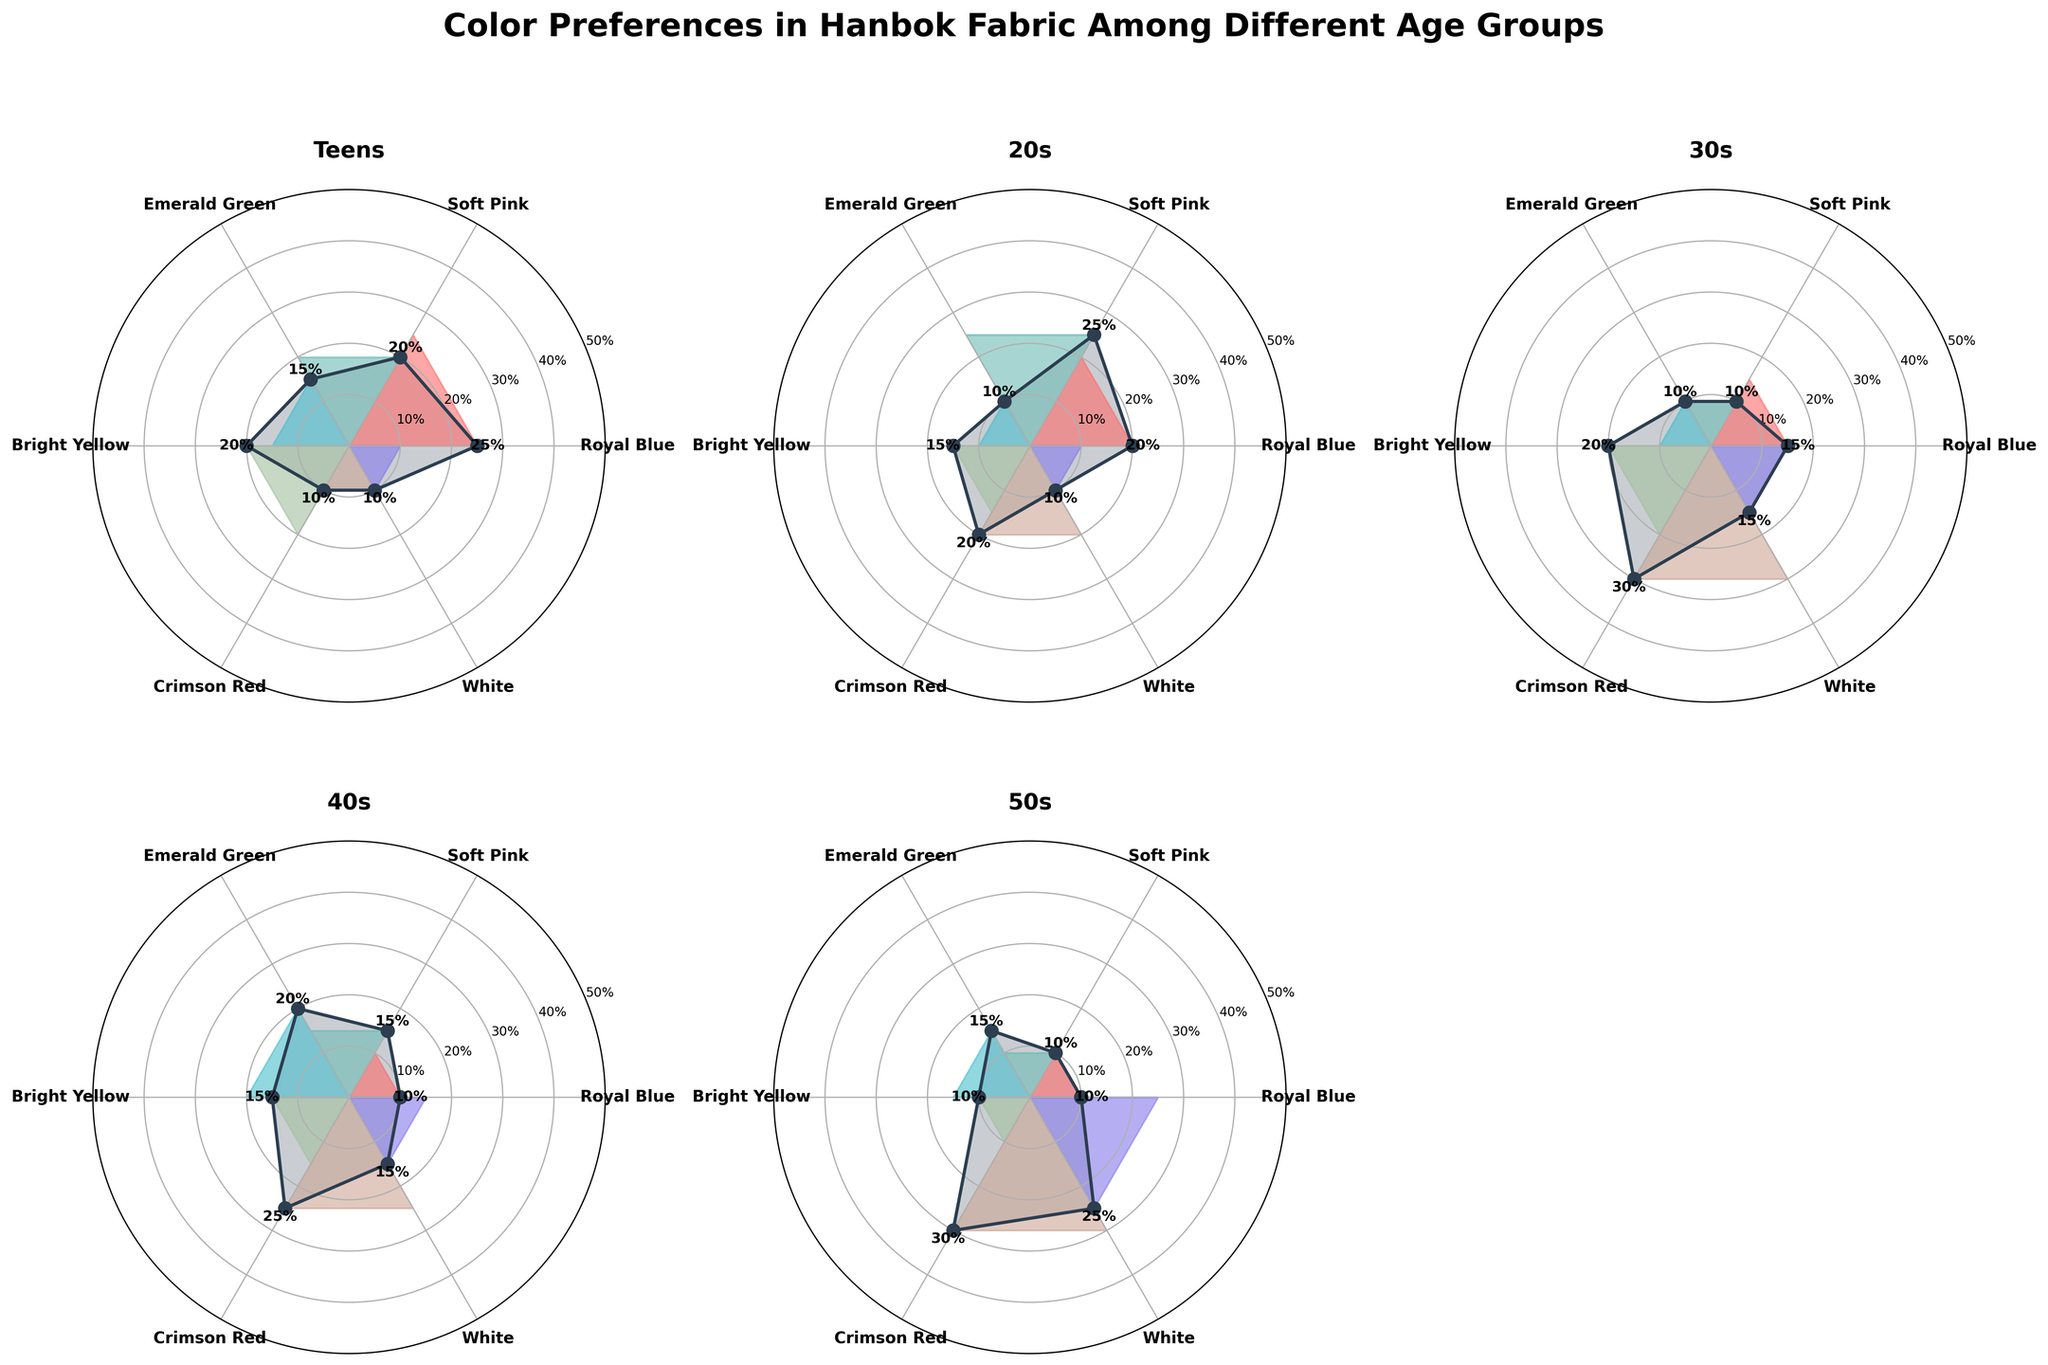Which age group has the highest preference for Royal Blue? By looking at the subplot for each age group, we see that "Teens" has the highest preference for Royal Blue at 25%.
Answer: Teens Which color is the most preferred among people in their 60s? Referring to the subplot for the 60+ age group, we see that White has the highest preference at 45%.
Answer: White How does the preference for Crimson Red change across different age groups? By examining each subplot, we can summarize the preference percentages for Crimson Red as follows: Teens (10%), 20s (20%), 30s (30%), 40s (25%), 50s (30%), 60+ (20%). The preference peaks in the 30s and 50s and is lowest in the Teens group.
Answer: Peaks in 30s and 50s, lowest in Teens What is the average preference percentage for Bright Yellow across all age groups? First, find the preferences for Bright Yellow for each age group: Teens (20%), 20s (15%), 30s (20%), 40s (15%), 50s (10%), 60+ (10%). Sum these values (20 + 15 + 20 + 15 + 10 + 10 = 90) and divide by the number of age groups (6). So, the average preference is 90/6 = 15%.
Answer: 15% Are there any colors preferred equally by two or more age groups? By examining the preference percentages for each color across all subplots, we find that White is preferred equally (10%) by Teens and people in their 20s and (15%) by 30s and 40s.
Answer: White - Teens & 20s (10%), 30s & 40s (15%) Which age group has the most diverse color preferences in terms of maximum differences between highest and lowest preferences? Calculating the difference between the highest and lowest preferences for each age group: Teens (25%-10%=15%), 20s (25%-10%=15%), 30s (30%-10%=20%), 40s (25%-10%=15%), 50s (30%-10%=20%), 60+ (45%-5%=40%). The 60+ age group has the largest difference (40%).
Answer: 60+ In which age group does Emerald Green have the highest preference? By looking at each subplot, people in their 40s have the highest preference for Emerald Green at 20%.
Answer: 40s How does the preference for Soft Pink change from the Teens group to the 50s group? The preferences for Soft Pink in the Teens, 20s, 30s, 40s, and 50s groups are 20%, 25%, 10%, 15%, and 10%, respectively. The preference increases from Teens (20%) to 20s (25%), then drops to 10% in the 30s and 50s groups.
Answer: Increases to 20s, then decreases Which age group has the lowest preference for Bright Yellow? From examining the subplots, the age groups 50s and 60+ both have the lowest preference for Bright Yellow at 10%.
Answer: 50s and 60+ What is the sum of the preferences for Crimson Red across all age groups? By summing the preferences for Crimson Red: Teens (10%), 20s (20%), 30s (30%), 40s (25%), 50s (30%), 60+ (20%). Adding these values gives 10 + 20 + 30 + 25 + 30 + 20 = 135.
Answer: 135 